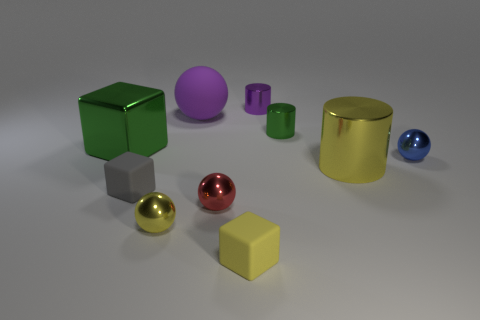Subtract all large purple matte balls. How many balls are left? 3 Subtract all yellow cylinders. How many cylinders are left? 2 Subtract 3 cubes. How many cubes are left? 0 Subtract 1 red balls. How many objects are left? 9 Subtract all balls. How many objects are left? 6 Subtract all cyan cylinders. Subtract all gray blocks. How many cylinders are left? 3 Subtract all gray cylinders. How many green cubes are left? 1 Subtract all big metal things. Subtract all large purple objects. How many objects are left? 7 Add 8 small green objects. How many small green objects are left? 9 Add 3 tiny green metal objects. How many tiny green metal objects exist? 4 